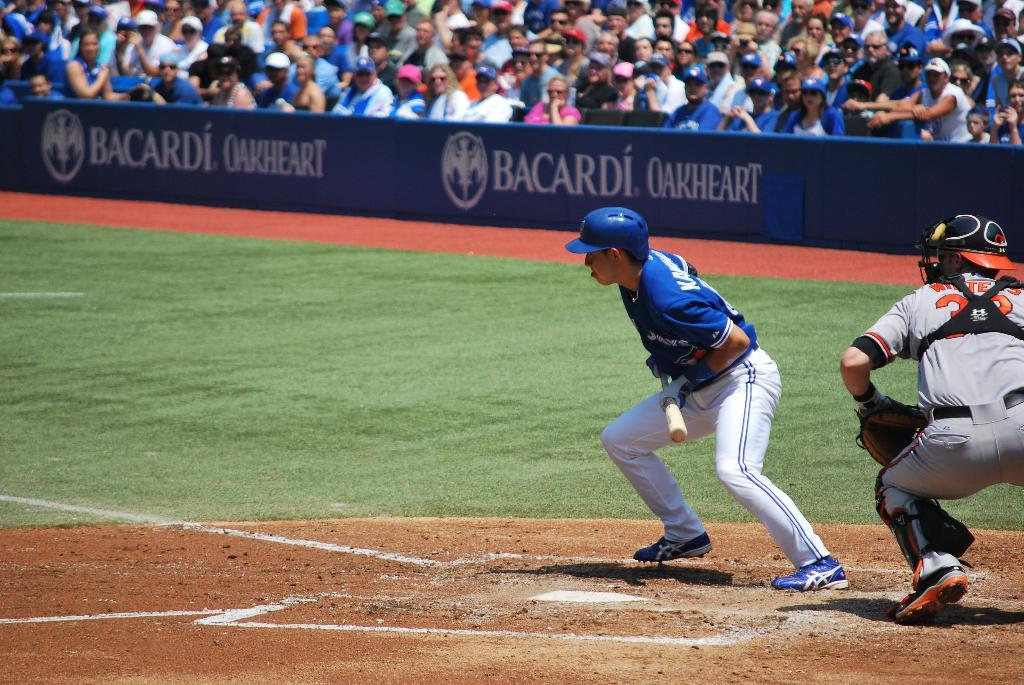<image>
Relay a brief, clear account of the picture shown. a man playing baseball and a Bacardi ad on it 